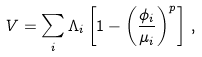Convert formula to latex. <formula><loc_0><loc_0><loc_500><loc_500>V = \sum _ { i } \Lambda _ { i } \left [ 1 - \left ( \frac { \phi _ { i } } { \mu _ { i } } \right ) ^ { p } \right ] \, ,</formula> 